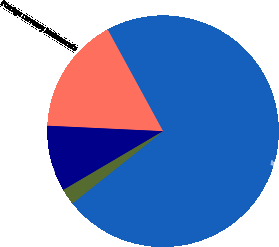Convert chart to OTSL. <chart><loc_0><loc_0><loc_500><loc_500><pie_chart><fcel>Interest rate instruments<fcel>Foreign currency instruments<fcel>Commodity instruments<fcel>Equity instruments<nl><fcel>72.23%<fcel>16.31%<fcel>9.23%<fcel>2.23%<nl></chart> 